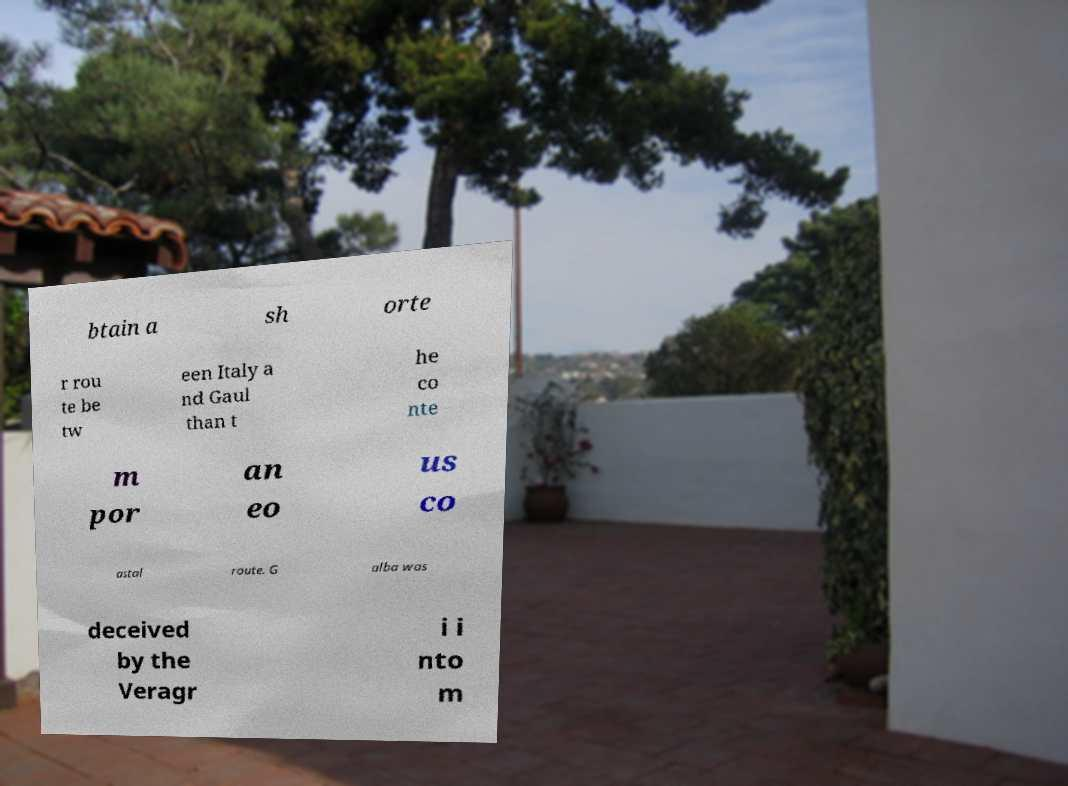Please read and relay the text visible in this image. What does it say? btain a sh orte r rou te be tw een Italy a nd Gaul than t he co nte m por an eo us co astal route. G alba was deceived by the Veragr i i nto m 